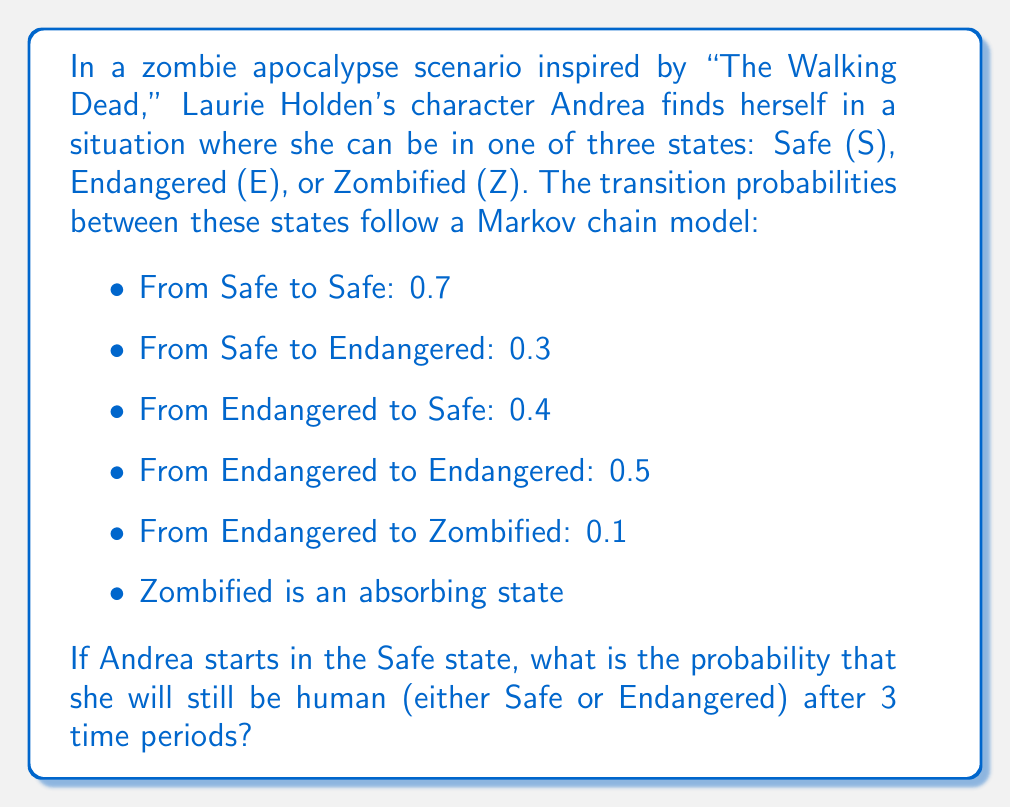Can you answer this question? To solve this problem, we'll use Markov chains and matrix multiplication. Let's follow these steps:

1) First, we need to set up the transition matrix P:

$$ P = \begin{bmatrix}
0.7 & 0.3 & 0 \\
0.4 & 0.5 & 0.1 \\
0 & 0 & 1
\end{bmatrix} $$

2) We want to know the state after 3 time periods, so we need to calculate $P^3$:

$$ P^3 = P \times P \times P $$

3) Let's calculate this step by step:

$$ P^2 = \begin{bmatrix}
0.7 & 0.3 & 0 \\
0.4 & 0.5 & 0.1 \\
0 & 0 & 1
\end{bmatrix} \times \begin{bmatrix}
0.7 & 0.3 & 0 \\
0.4 & 0.5 & 0.1 \\
0 & 0 & 1
\end{bmatrix} = \begin{bmatrix}
0.61 & 0.36 & 0.03 \\
0.48 & 0.46 & 0.06 \\
0 & 0 & 1
\end{bmatrix} $$

$$ P^3 = P^2 \times P = \begin{bmatrix}
0.61 & 0.36 & 0.03 \\
0.48 & 0.46 & 0.06 \\
0 & 0 & 1
\end{bmatrix} \times \begin{bmatrix}
0.7 & 0.3 & 0 \\
0.4 & 0.5 & 0.1 \\
0 & 0 & 1
\end{bmatrix} = \begin{bmatrix}
0.571 & 0.387 & 0.042 \\
0.512 & 0.426 & 0.062 \\
0 & 0 & 1
\end{bmatrix} $$

4) Andrea starts in the Safe state, which is represented by the vector $[1, 0, 0]$.

5) To find the probability distribution after 3 time periods, we multiply this initial state vector by $P^3$:

$$ [1, 0, 0] \times \begin{bmatrix}
0.571 & 0.387 & 0.042 \\
0.512 & 0.426 & 0.062 \\
0 & 0 & 1
\end{bmatrix} = [0.571, 0.387, 0.042] $$

6) The probability of still being human is the sum of the probabilities of being in the Safe or Endangered state:

$$ P(\text{human}) = P(\text{Safe}) + P(\text{Endangered}) = 0.571 + 0.387 = 0.958 $$
Answer: The probability that Andrea will still be human after 3 time periods is 0.958 or 95.8%. 